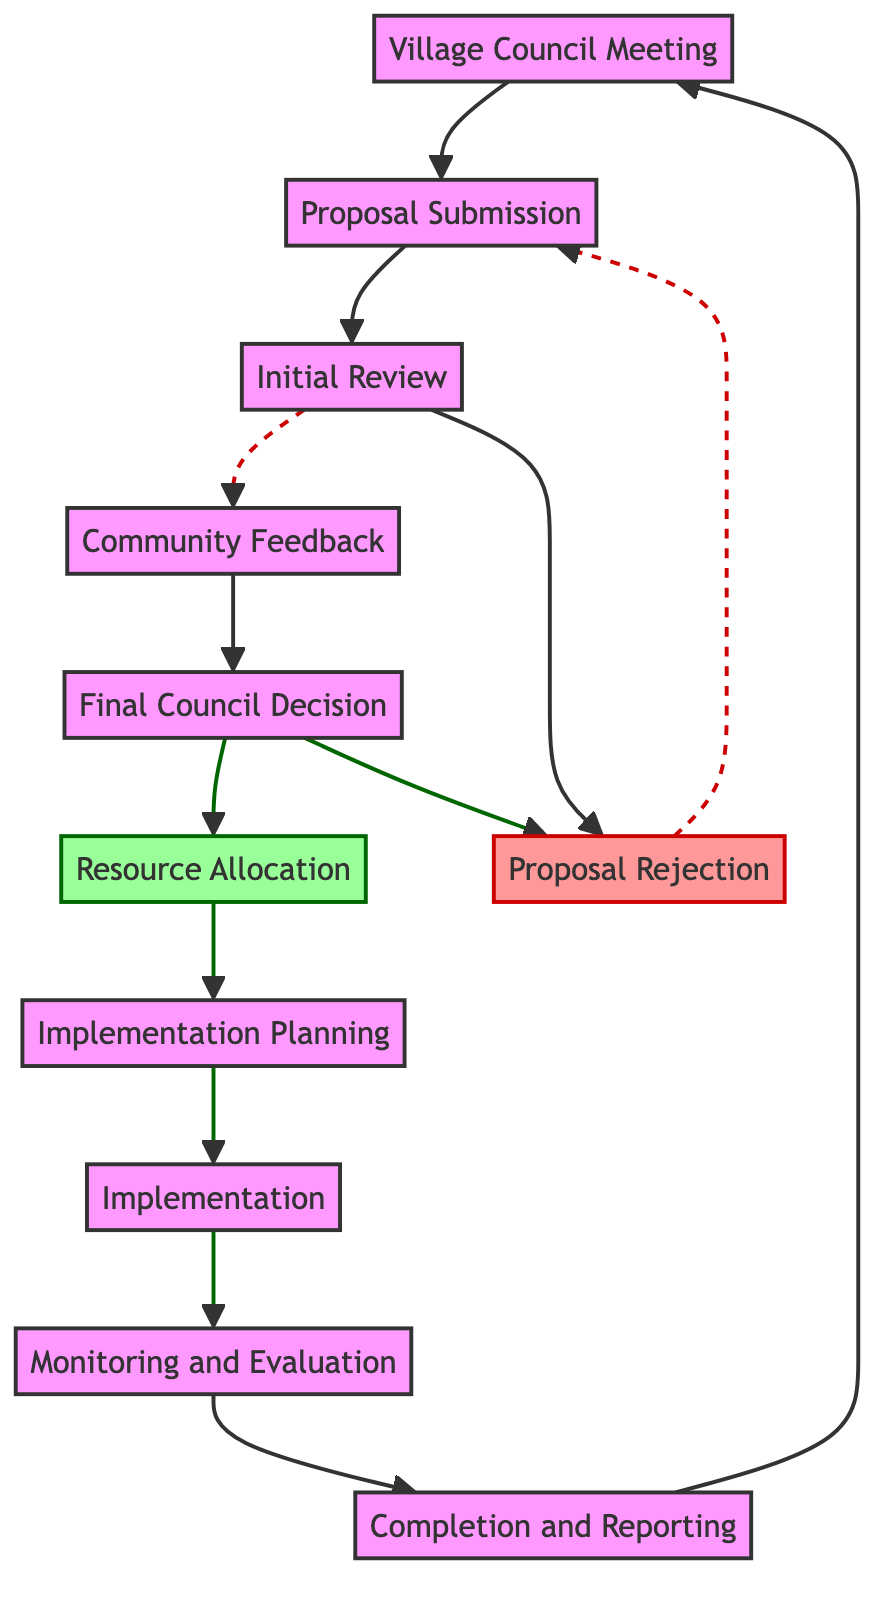What is the starting point of the decision-making process? The decision-making process begins at the "Village Council Meeting" node, which is the first step in the process and initiates the flow of actions.
Answer: Village Council Meeting How many steps are there from Proposal Submission to Implementation? The steps are Proposal Submission, Initial Review, Community Feedback, Final Council Decision, Resource Allocation, Implementation Planning, and Implementation. Counting these gives us seven steps.
Answer: 7 Which node represents the feedback process? The node labeled "Community Feedback" signifies the gathering of opinions from villagers, as indicated between the Initial Review and Final Council Decision nodes.
Answer: Community Feedback What happens if a proposal is rejected? If a proposal is rejected in the Final Council Decision step, it loops back to Proposal Submission for revisions, indicating a recycling of ideas for improvement.
Answer: Proposal Rejection What is the final step in the decision-making process? The last step in the sequence is "Completion and Reporting," which signifies the finalization of the project and reporting back to the Village Council.
Answer: Completion and Reporting How many nodes in the diagram are labeled as approved? The nodes labeled as approved include "Final Council Decision" and "Resource Allocation," totaling two approved nodes in the decision-making process.
Answer: 2 Which node occurs immediately after Implementation Planning? Directly following Implementation Planning is the "Implementation" node, marking the execution phase of the approved proposal.
Answer: Implementation Which node leads to Monitoring and Evaluation? The "Implementation" node leads directly to "Monitoring and Evaluation," indicating the oversight phase of the project's progress and impact.
Answer: Implementation What is the direct outcome of the Monitoring and Evaluation phase? The outcome of the Monitoring and Evaluation phase is the "Completion and Reporting" step, which concludes the decision-making process.
Answer: Completion and Reporting 